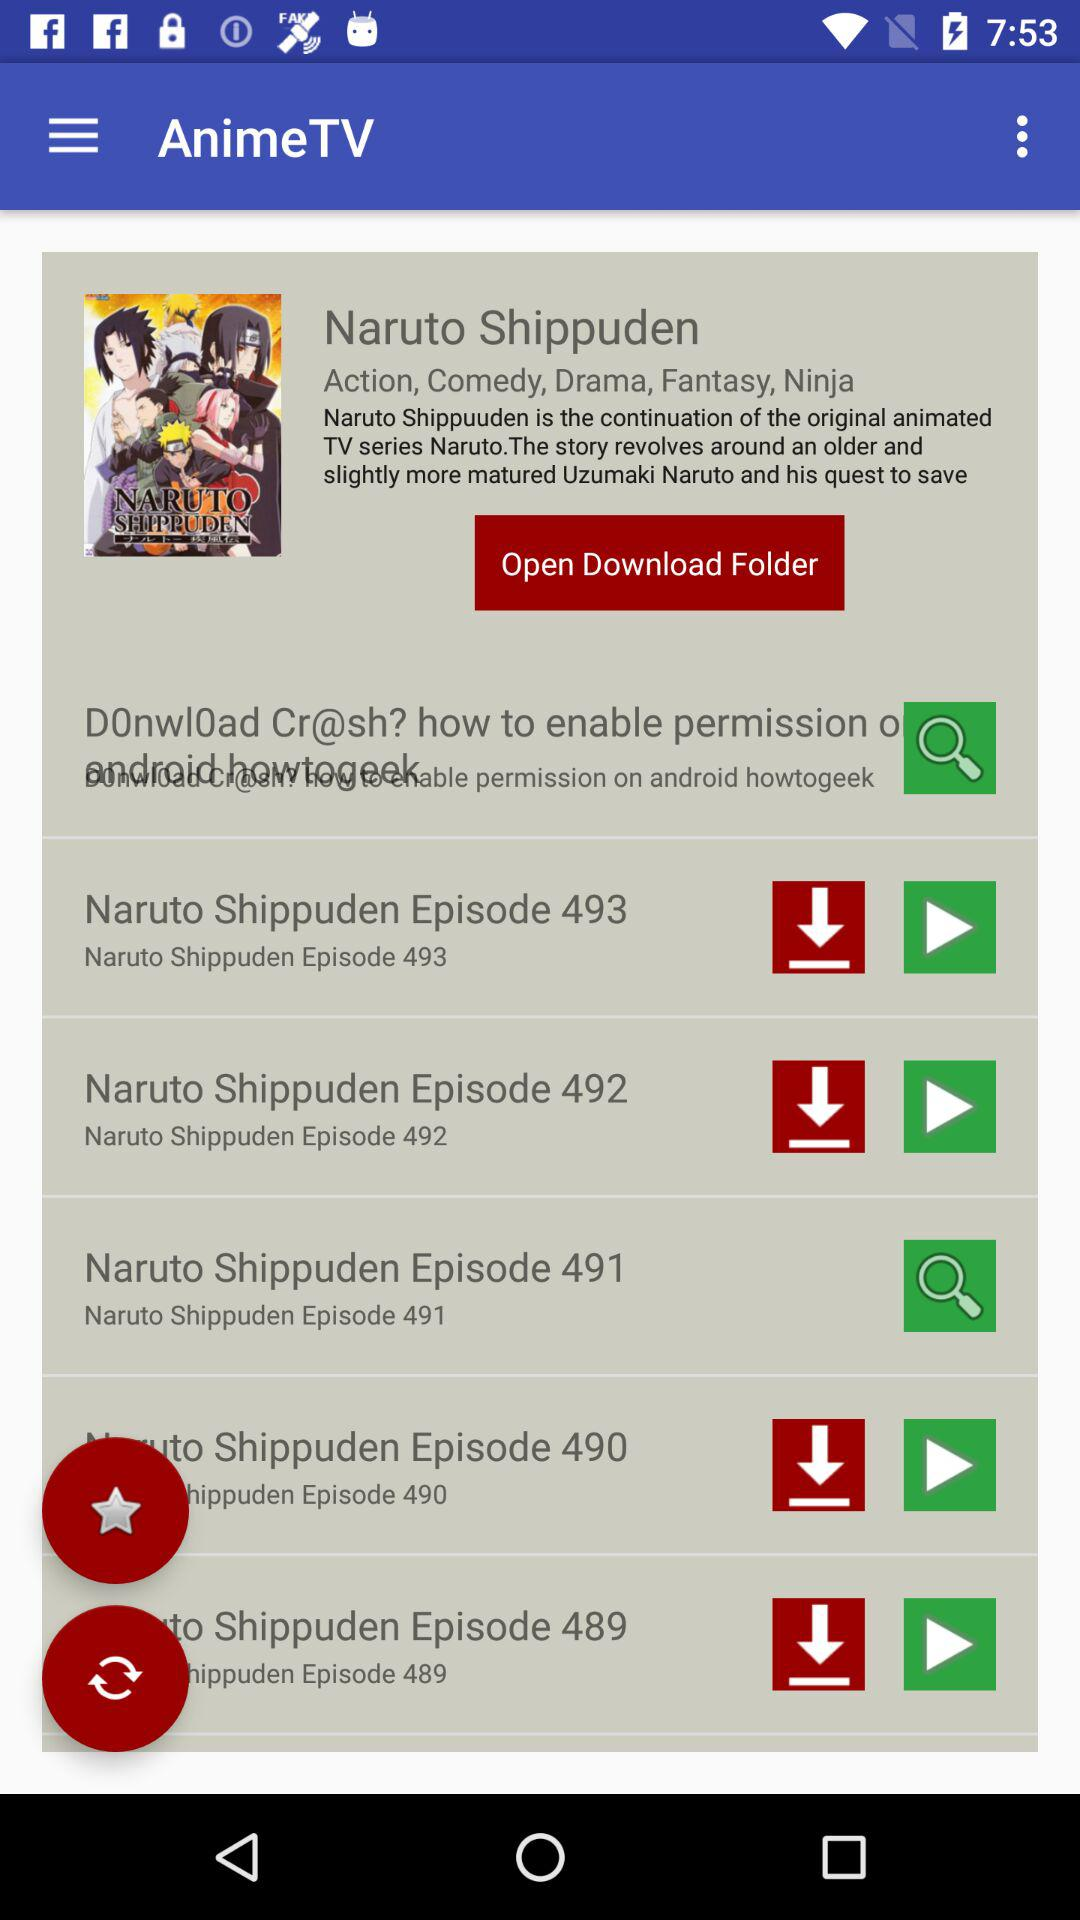What is the application name? The application name is "AnimeTV". 